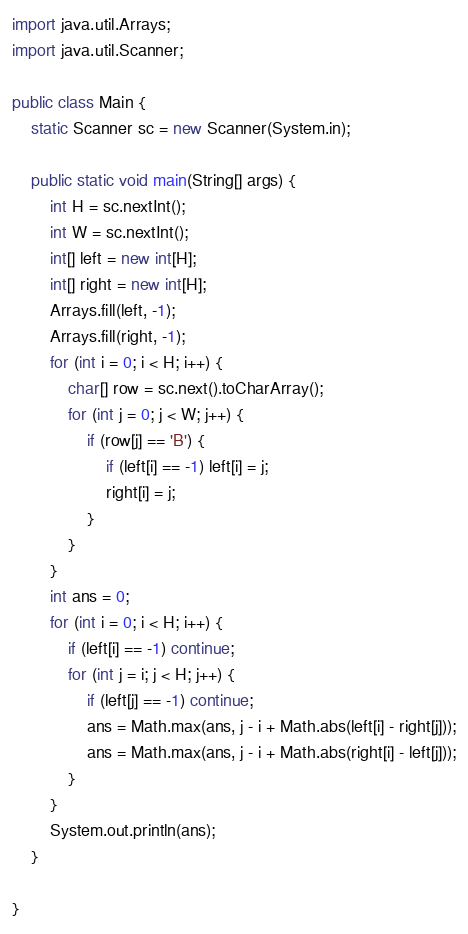Convert code to text. <code><loc_0><loc_0><loc_500><loc_500><_Java_>import java.util.Arrays;
import java.util.Scanner;

public class Main {
	static Scanner sc = new Scanner(System.in);

	public static void main(String[] args) {
		int H = sc.nextInt();
		int W = sc.nextInt();
		int[] left = new int[H];
		int[] right = new int[H];
		Arrays.fill(left, -1);
		Arrays.fill(right, -1);
		for (int i = 0; i < H; i++) {
			char[] row = sc.next().toCharArray();
			for (int j = 0; j < W; j++) {
				if (row[j] == 'B') {
					if (left[i] == -1) left[i] = j;
					right[i] = j;
				}
			}
		}
		int ans = 0;
		for (int i = 0; i < H; i++) {
			if (left[i] == -1) continue;
			for (int j = i; j < H; j++) {
				if (left[j] == -1) continue;
				ans = Math.max(ans, j - i + Math.abs(left[i] - right[j]));
				ans = Math.max(ans, j - i + Math.abs(right[i] - left[j]));
			}
		}
		System.out.println(ans);
	}

}

</code> 